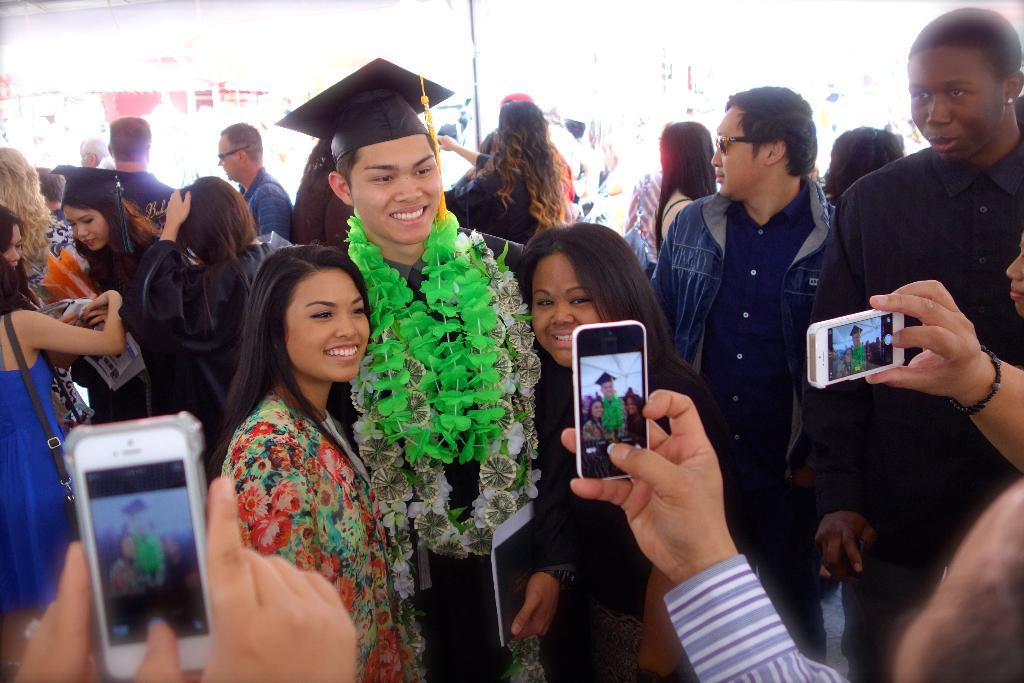What event is the image depicting? The image is from a graduation function. How many people are present in the image? There are many people in the image. What are some people doing in the image? Some people are taking pictures. What type of clothing are some people wearing in the image? There are people wearing graduation dress in the image. What decorative items can be seen in the image? Garlands are present in the image. What type of support can be seen holding up the table in the image? There is no table present in the image, so there is no support holding it up. What type of fork is being used to eat the cake in the image? There is no cake or fork present in the image. 